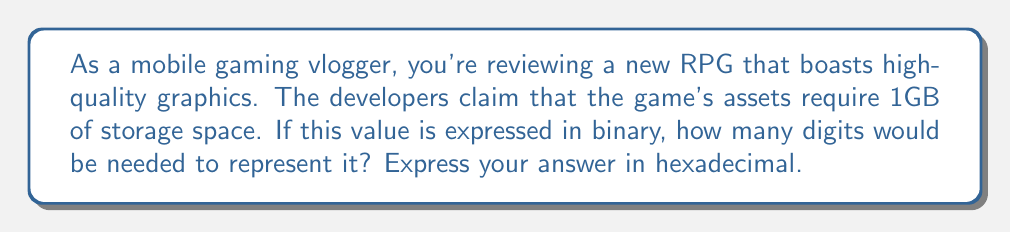Solve this math problem. Let's approach this step-by-step:

1) First, we need to convert 1GB to bits:
   1GB = $1 \times 2^{30}$ bytes (since 1GB = $2^{30}$ bytes)
   1 byte = 8 bits
   So, 1GB in bits = $1 \times 2^{30} \times 8 = 2^{33}$ bits

2) Now, we need to find how many binary digits are needed to represent $2^{33}$:
   In binary, $2^{33}$ is represented as 1 followed by 33 zeros.
   Therefore, the number of binary digits needed is 34.

3) The question asks for the answer in hexadecimal. So, we need to convert 34 to hexadecimal:
   
   $34 \div 16 = 2$ remainder $2$
   
   In hexadecimal notation:
   2 is represented as 2
   2 is represented as 2

   Therefore, 34 in hexadecimal is 22.
Answer: $$22_{16}$$ 